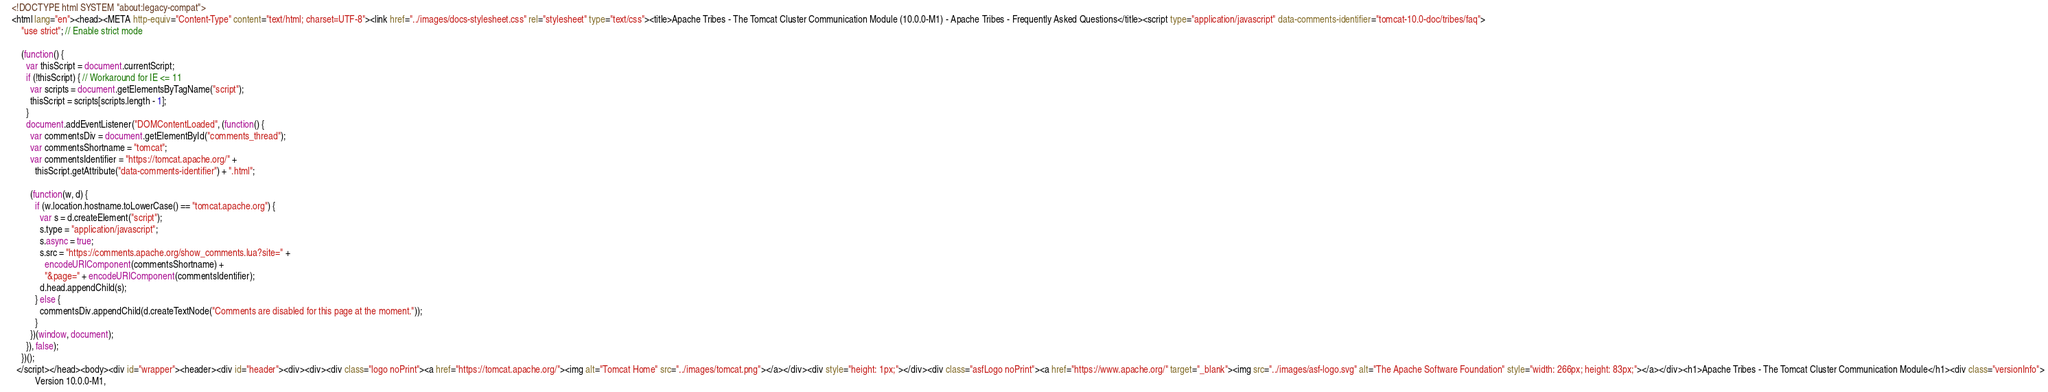<code> <loc_0><loc_0><loc_500><loc_500><_HTML_><!DOCTYPE html SYSTEM "about:legacy-compat">
<html lang="en"><head><META http-equiv="Content-Type" content="text/html; charset=UTF-8"><link href="../images/docs-stylesheet.css" rel="stylesheet" type="text/css"><title>Apache Tribes - The Tomcat Cluster Communication Module (10.0.0-M1) - Apache Tribes - Frequently Asked Questions</title><script type="application/javascript" data-comments-identifier="tomcat-10.0-doc/tribes/faq">
    "use strict"; // Enable strict mode

    (function() {
      var thisScript = document.currentScript;
      if (!thisScript) { // Workaround for IE <= 11
        var scripts = document.getElementsByTagName("script");
        thisScript = scripts[scripts.length - 1];
      }
      document.addEventListener("DOMContentLoaded", (function() {
        var commentsDiv = document.getElementById("comments_thread");
        var commentsShortname = "tomcat";
        var commentsIdentifier = "https://tomcat.apache.org/" +
          thisScript.getAttribute("data-comments-identifier") + ".html";

        (function(w, d) {
          if (w.location.hostname.toLowerCase() == "tomcat.apache.org") {
            var s = d.createElement("script");
            s.type = "application/javascript";
            s.async = true;
            s.src = "https://comments.apache.org/show_comments.lua?site=" +
              encodeURIComponent(commentsShortname) +
              "&page=" + encodeURIComponent(commentsIdentifier);
            d.head.appendChild(s);
          } else {
            commentsDiv.appendChild(d.createTextNode("Comments are disabled for this page at the moment."));
          }
        })(window, document);
      }), false);
    })();
  </script></head><body><div id="wrapper"><header><div id="header"><div><div><div class="logo noPrint"><a href="https://tomcat.apache.org/"><img alt="Tomcat Home" src="../images/tomcat.png"></a></div><div style="height: 1px;"></div><div class="asfLogo noPrint"><a href="https://www.apache.org/" target="_blank"><img src="../images/asf-logo.svg" alt="The Apache Software Foundation" style="width: 266px; height: 83px;"></a></div><h1>Apache Tribes - The Tomcat Cluster Communication Module</h1><div class="versionInfo">
          Version 10.0.0-M1,</code> 